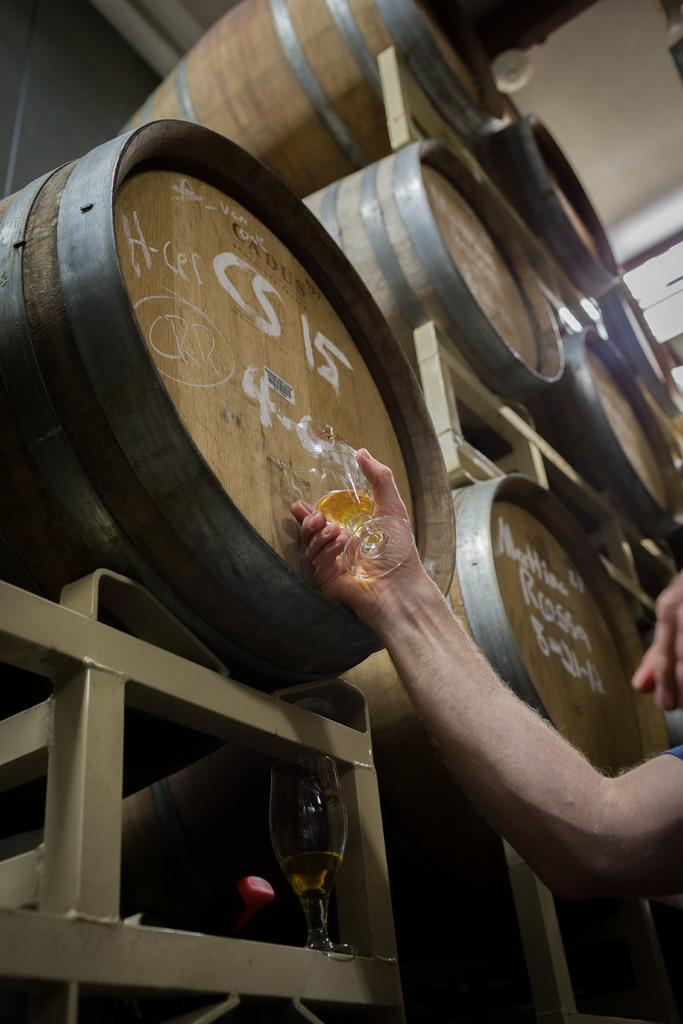<image>
Write a terse but informative summary of the picture. Some wooden barrels with, one of which has the letters CS on. 